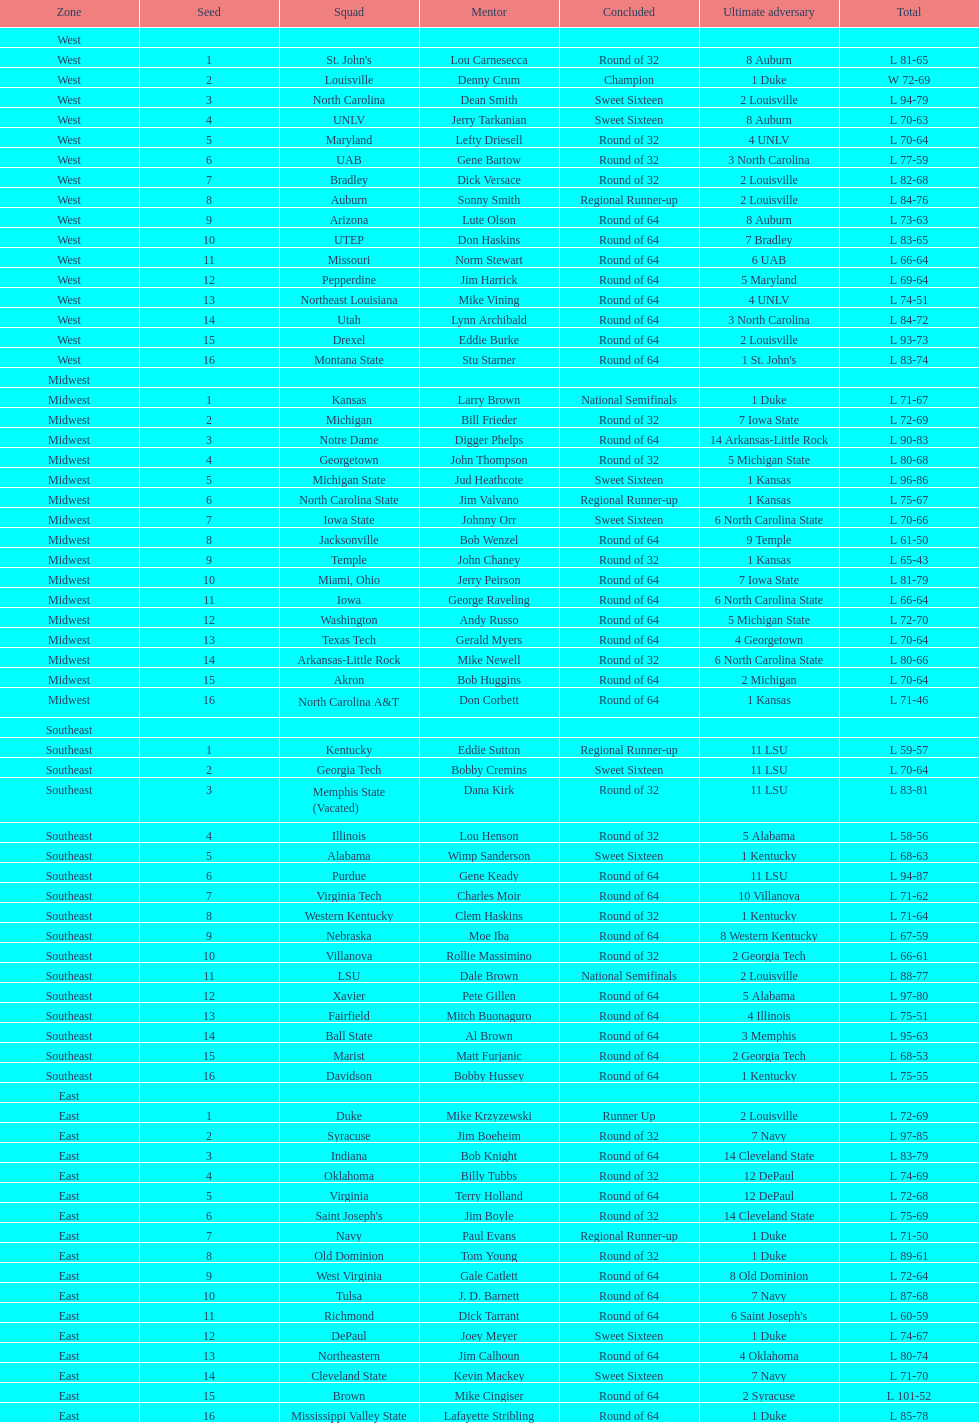Who was the only champion? Louisville. 